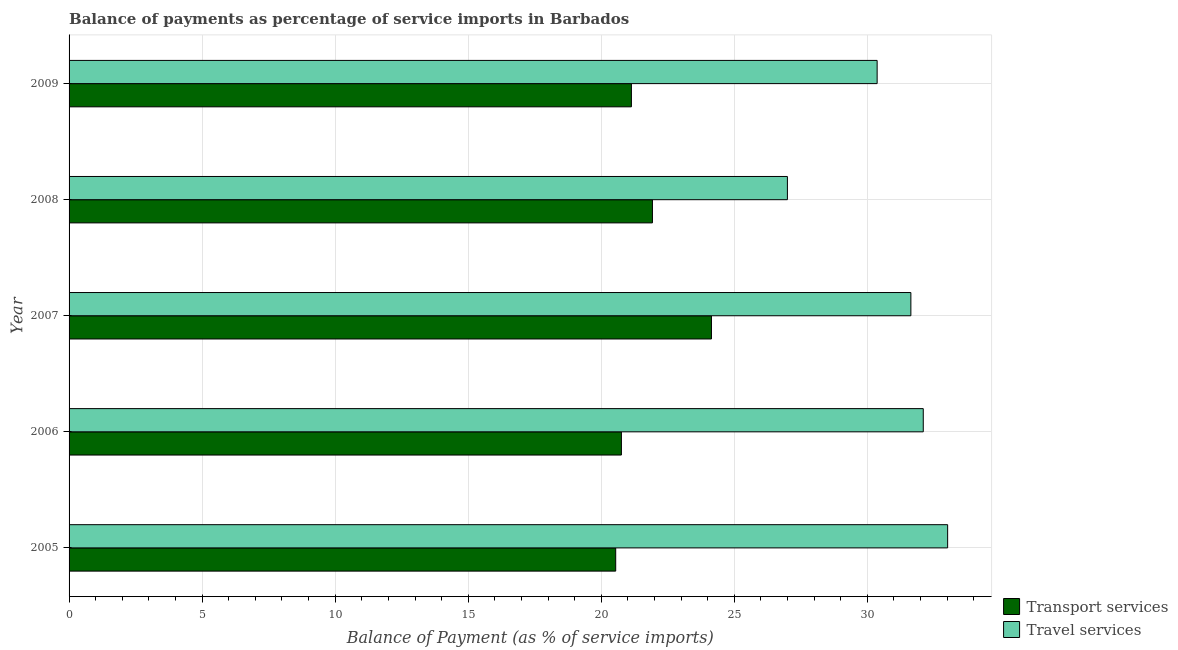How many different coloured bars are there?
Your answer should be very brief. 2. How many groups of bars are there?
Give a very brief answer. 5. Are the number of bars per tick equal to the number of legend labels?
Offer a very short reply. Yes. Are the number of bars on each tick of the Y-axis equal?
Make the answer very short. Yes. How many bars are there on the 2nd tick from the bottom?
Ensure brevity in your answer.  2. What is the label of the 1st group of bars from the top?
Ensure brevity in your answer.  2009. What is the balance of payments of travel services in 2008?
Offer a terse response. 26.99. Across all years, what is the maximum balance of payments of transport services?
Offer a terse response. 24.14. Across all years, what is the minimum balance of payments of travel services?
Offer a terse response. 26.99. What is the total balance of payments of travel services in the graph?
Offer a very short reply. 154.11. What is the difference between the balance of payments of transport services in 2006 and that in 2009?
Make the answer very short. -0.38. What is the difference between the balance of payments of transport services in 2008 and the balance of payments of travel services in 2009?
Provide a succinct answer. -8.44. What is the average balance of payments of travel services per year?
Make the answer very short. 30.82. In the year 2009, what is the difference between the balance of payments of transport services and balance of payments of travel services?
Give a very brief answer. -9.23. In how many years, is the balance of payments of transport services greater than 19 %?
Provide a succinct answer. 5. What is the ratio of the balance of payments of travel services in 2005 to that in 2009?
Make the answer very short. 1.09. Is the balance of payments of travel services in 2008 less than that in 2009?
Your answer should be compact. Yes. What is the difference between the highest and the second highest balance of payments of transport services?
Ensure brevity in your answer.  2.22. What is the difference between the highest and the lowest balance of payments of travel services?
Keep it short and to the point. 6.02. Is the sum of the balance of payments of transport services in 2005 and 2008 greater than the maximum balance of payments of travel services across all years?
Your response must be concise. Yes. What does the 1st bar from the top in 2006 represents?
Ensure brevity in your answer.  Travel services. What does the 2nd bar from the bottom in 2008 represents?
Provide a succinct answer. Travel services. How many bars are there?
Keep it short and to the point. 10. Are all the bars in the graph horizontal?
Offer a terse response. Yes. How many years are there in the graph?
Your answer should be very brief. 5. What is the difference between two consecutive major ticks on the X-axis?
Your response must be concise. 5. Are the values on the major ticks of X-axis written in scientific E-notation?
Your answer should be compact. No. Does the graph contain any zero values?
Offer a very short reply. No. Does the graph contain grids?
Provide a succinct answer. Yes. How many legend labels are there?
Give a very brief answer. 2. How are the legend labels stacked?
Your answer should be very brief. Vertical. What is the title of the graph?
Offer a terse response. Balance of payments as percentage of service imports in Barbados. Does "Taxes" appear as one of the legend labels in the graph?
Make the answer very short. No. What is the label or title of the X-axis?
Offer a very short reply. Balance of Payment (as % of service imports). What is the label or title of the Y-axis?
Ensure brevity in your answer.  Year. What is the Balance of Payment (as % of service imports) of Transport services in 2005?
Offer a very short reply. 20.54. What is the Balance of Payment (as % of service imports) in Travel services in 2005?
Keep it short and to the point. 33.02. What is the Balance of Payment (as % of service imports) of Transport services in 2006?
Offer a very short reply. 20.76. What is the Balance of Payment (as % of service imports) in Travel services in 2006?
Your answer should be very brief. 32.1. What is the Balance of Payment (as % of service imports) in Transport services in 2007?
Offer a very short reply. 24.14. What is the Balance of Payment (as % of service imports) in Travel services in 2007?
Your answer should be compact. 31.64. What is the Balance of Payment (as % of service imports) in Transport services in 2008?
Your answer should be very brief. 21.92. What is the Balance of Payment (as % of service imports) of Travel services in 2008?
Offer a terse response. 26.99. What is the Balance of Payment (as % of service imports) of Transport services in 2009?
Your response must be concise. 21.13. What is the Balance of Payment (as % of service imports) of Travel services in 2009?
Provide a short and direct response. 30.37. Across all years, what is the maximum Balance of Payment (as % of service imports) of Transport services?
Give a very brief answer. 24.14. Across all years, what is the maximum Balance of Payment (as % of service imports) in Travel services?
Provide a short and direct response. 33.02. Across all years, what is the minimum Balance of Payment (as % of service imports) of Transport services?
Your answer should be compact. 20.54. Across all years, what is the minimum Balance of Payment (as % of service imports) in Travel services?
Provide a short and direct response. 26.99. What is the total Balance of Payment (as % of service imports) of Transport services in the graph?
Your answer should be compact. 108.5. What is the total Balance of Payment (as % of service imports) of Travel services in the graph?
Give a very brief answer. 154.11. What is the difference between the Balance of Payment (as % of service imports) of Transport services in 2005 and that in 2006?
Your response must be concise. -0.21. What is the difference between the Balance of Payment (as % of service imports) in Travel services in 2005 and that in 2006?
Your response must be concise. 0.92. What is the difference between the Balance of Payment (as % of service imports) of Transport services in 2005 and that in 2007?
Your answer should be very brief. -3.6. What is the difference between the Balance of Payment (as % of service imports) of Travel services in 2005 and that in 2007?
Your answer should be very brief. 1.38. What is the difference between the Balance of Payment (as % of service imports) of Transport services in 2005 and that in 2008?
Ensure brevity in your answer.  -1.38. What is the difference between the Balance of Payment (as % of service imports) in Travel services in 2005 and that in 2008?
Offer a terse response. 6.02. What is the difference between the Balance of Payment (as % of service imports) in Transport services in 2005 and that in 2009?
Ensure brevity in your answer.  -0.59. What is the difference between the Balance of Payment (as % of service imports) in Travel services in 2005 and that in 2009?
Your answer should be very brief. 2.65. What is the difference between the Balance of Payment (as % of service imports) of Transport services in 2006 and that in 2007?
Keep it short and to the point. -3.38. What is the difference between the Balance of Payment (as % of service imports) in Travel services in 2006 and that in 2007?
Give a very brief answer. 0.47. What is the difference between the Balance of Payment (as % of service imports) of Transport services in 2006 and that in 2008?
Keep it short and to the point. -1.17. What is the difference between the Balance of Payment (as % of service imports) in Travel services in 2006 and that in 2008?
Your answer should be compact. 5.11. What is the difference between the Balance of Payment (as % of service imports) of Transport services in 2006 and that in 2009?
Provide a short and direct response. -0.38. What is the difference between the Balance of Payment (as % of service imports) in Travel services in 2006 and that in 2009?
Offer a terse response. 1.73. What is the difference between the Balance of Payment (as % of service imports) in Transport services in 2007 and that in 2008?
Ensure brevity in your answer.  2.22. What is the difference between the Balance of Payment (as % of service imports) of Travel services in 2007 and that in 2008?
Make the answer very short. 4.64. What is the difference between the Balance of Payment (as % of service imports) in Transport services in 2007 and that in 2009?
Your response must be concise. 3.01. What is the difference between the Balance of Payment (as % of service imports) of Travel services in 2007 and that in 2009?
Your answer should be compact. 1.27. What is the difference between the Balance of Payment (as % of service imports) in Transport services in 2008 and that in 2009?
Your response must be concise. 0.79. What is the difference between the Balance of Payment (as % of service imports) of Travel services in 2008 and that in 2009?
Ensure brevity in your answer.  -3.37. What is the difference between the Balance of Payment (as % of service imports) of Transport services in 2005 and the Balance of Payment (as % of service imports) of Travel services in 2006?
Provide a short and direct response. -11.56. What is the difference between the Balance of Payment (as % of service imports) in Transport services in 2005 and the Balance of Payment (as % of service imports) in Travel services in 2007?
Ensure brevity in your answer.  -11.09. What is the difference between the Balance of Payment (as % of service imports) of Transport services in 2005 and the Balance of Payment (as % of service imports) of Travel services in 2008?
Provide a short and direct response. -6.45. What is the difference between the Balance of Payment (as % of service imports) of Transport services in 2005 and the Balance of Payment (as % of service imports) of Travel services in 2009?
Provide a short and direct response. -9.82. What is the difference between the Balance of Payment (as % of service imports) in Transport services in 2006 and the Balance of Payment (as % of service imports) in Travel services in 2007?
Keep it short and to the point. -10.88. What is the difference between the Balance of Payment (as % of service imports) of Transport services in 2006 and the Balance of Payment (as % of service imports) of Travel services in 2008?
Keep it short and to the point. -6.24. What is the difference between the Balance of Payment (as % of service imports) of Transport services in 2006 and the Balance of Payment (as % of service imports) of Travel services in 2009?
Your response must be concise. -9.61. What is the difference between the Balance of Payment (as % of service imports) of Transport services in 2007 and the Balance of Payment (as % of service imports) of Travel services in 2008?
Your answer should be compact. -2.85. What is the difference between the Balance of Payment (as % of service imports) in Transport services in 2007 and the Balance of Payment (as % of service imports) in Travel services in 2009?
Provide a short and direct response. -6.23. What is the difference between the Balance of Payment (as % of service imports) in Transport services in 2008 and the Balance of Payment (as % of service imports) in Travel services in 2009?
Ensure brevity in your answer.  -8.44. What is the average Balance of Payment (as % of service imports) of Transport services per year?
Offer a terse response. 21.7. What is the average Balance of Payment (as % of service imports) of Travel services per year?
Offer a terse response. 30.82. In the year 2005, what is the difference between the Balance of Payment (as % of service imports) of Transport services and Balance of Payment (as % of service imports) of Travel services?
Offer a terse response. -12.47. In the year 2006, what is the difference between the Balance of Payment (as % of service imports) in Transport services and Balance of Payment (as % of service imports) in Travel services?
Your answer should be very brief. -11.34. In the year 2007, what is the difference between the Balance of Payment (as % of service imports) of Transport services and Balance of Payment (as % of service imports) of Travel services?
Keep it short and to the point. -7.49. In the year 2008, what is the difference between the Balance of Payment (as % of service imports) of Transport services and Balance of Payment (as % of service imports) of Travel services?
Provide a succinct answer. -5.07. In the year 2009, what is the difference between the Balance of Payment (as % of service imports) of Transport services and Balance of Payment (as % of service imports) of Travel services?
Your response must be concise. -9.23. What is the ratio of the Balance of Payment (as % of service imports) in Travel services in 2005 to that in 2006?
Provide a succinct answer. 1.03. What is the ratio of the Balance of Payment (as % of service imports) of Transport services in 2005 to that in 2007?
Your response must be concise. 0.85. What is the ratio of the Balance of Payment (as % of service imports) of Travel services in 2005 to that in 2007?
Give a very brief answer. 1.04. What is the ratio of the Balance of Payment (as % of service imports) in Transport services in 2005 to that in 2008?
Give a very brief answer. 0.94. What is the ratio of the Balance of Payment (as % of service imports) in Travel services in 2005 to that in 2008?
Provide a short and direct response. 1.22. What is the ratio of the Balance of Payment (as % of service imports) in Transport services in 2005 to that in 2009?
Provide a short and direct response. 0.97. What is the ratio of the Balance of Payment (as % of service imports) of Travel services in 2005 to that in 2009?
Offer a very short reply. 1.09. What is the ratio of the Balance of Payment (as % of service imports) in Transport services in 2006 to that in 2007?
Give a very brief answer. 0.86. What is the ratio of the Balance of Payment (as % of service imports) of Travel services in 2006 to that in 2007?
Your answer should be very brief. 1.01. What is the ratio of the Balance of Payment (as % of service imports) in Transport services in 2006 to that in 2008?
Your answer should be very brief. 0.95. What is the ratio of the Balance of Payment (as % of service imports) of Travel services in 2006 to that in 2008?
Give a very brief answer. 1.19. What is the ratio of the Balance of Payment (as % of service imports) in Transport services in 2006 to that in 2009?
Keep it short and to the point. 0.98. What is the ratio of the Balance of Payment (as % of service imports) in Travel services in 2006 to that in 2009?
Offer a terse response. 1.06. What is the ratio of the Balance of Payment (as % of service imports) of Transport services in 2007 to that in 2008?
Provide a succinct answer. 1.1. What is the ratio of the Balance of Payment (as % of service imports) of Travel services in 2007 to that in 2008?
Provide a succinct answer. 1.17. What is the ratio of the Balance of Payment (as % of service imports) in Transport services in 2007 to that in 2009?
Offer a very short reply. 1.14. What is the ratio of the Balance of Payment (as % of service imports) in Travel services in 2007 to that in 2009?
Keep it short and to the point. 1.04. What is the ratio of the Balance of Payment (as % of service imports) of Transport services in 2008 to that in 2009?
Your answer should be very brief. 1.04. What is the difference between the highest and the second highest Balance of Payment (as % of service imports) in Transport services?
Your answer should be very brief. 2.22. What is the difference between the highest and the second highest Balance of Payment (as % of service imports) of Travel services?
Your answer should be very brief. 0.92. What is the difference between the highest and the lowest Balance of Payment (as % of service imports) of Transport services?
Make the answer very short. 3.6. What is the difference between the highest and the lowest Balance of Payment (as % of service imports) in Travel services?
Your answer should be compact. 6.02. 